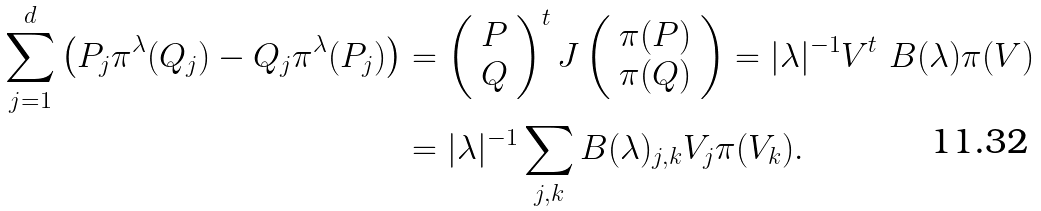Convert formula to latex. <formula><loc_0><loc_0><loc_500><loc_500>\sum _ { j = 1 } ^ { d } \left ( P _ { j } \pi ^ { \lambda } ( Q _ { j } ) - Q _ { j } \pi ^ { \lambda } ( P _ { j } ) \right ) & = \left ( \begin{array} { c } P \\ Q \end{array} \right ) ^ { t } J \left ( \begin{array} { c } \pi ( P ) \\ \pi ( Q ) \end{array} \right ) = | \lambda | ^ { - 1 } V ^ { t } \ B ( \lambda ) \pi ( V ) \\ & = | \lambda | ^ { - 1 } \sum _ { j , k } B ( \lambda ) _ { j , k } V _ { j } \pi ( V _ { k } ) .</formula> 